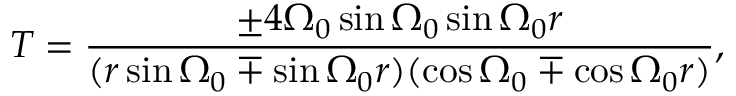Convert formula to latex. <formula><loc_0><loc_0><loc_500><loc_500>T = \frac { \pm 4 \Omega _ { 0 } \sin \Omega _ { 0 } \sin \Omega _ { 0 } r } { ( r \sin \Omega _ { 0 } \mp \sin \Omega _ { 0 } r ) ( \cos \Omega _ { 0 } \mp \cos \Omega _ { 0 } r ) } ,</formula> 